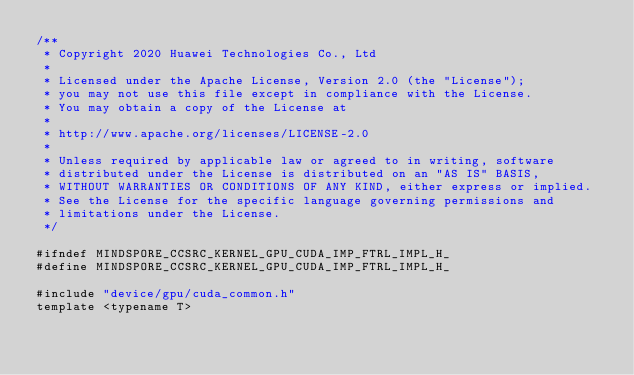Convert code to text. <code><loc_0><loc_0><loc_500><loc_500><_Cuda_>/**
 * Copyright 2020 Huawei Technologies Co., Ltd
 *
 * Licensed under the Apache License, Version 2.0 (the "License");
 * you may not use this file except in compliance with the License.
 * You may obtain a copy of the License at
 *
 * http://www.apache.org/licenses/LICENSE-2.0
 *
 * Unless required by applicable law or agreed to in writing, software
 * distributed under the License is distributed on an "AS IS" BASIS,
 * WITHOUT WARRANTIES OR CONDITIONS OF ANY KIND, either express or implied.
 * See the License for the specific language governing permissions and
 * limitations under the License.
 */

#ifndef MINDSPORE_CCSRC_KERNEL_GPU_CUDA_IMP_FTRL_IMPL_H_
#define MINDSPORE_CCSRC_KERNEL_GPU_CUDA_IMP_FTRL_IMPL_H_

#include "device/gpu/cuda_common.h"
template <typename T></code> 